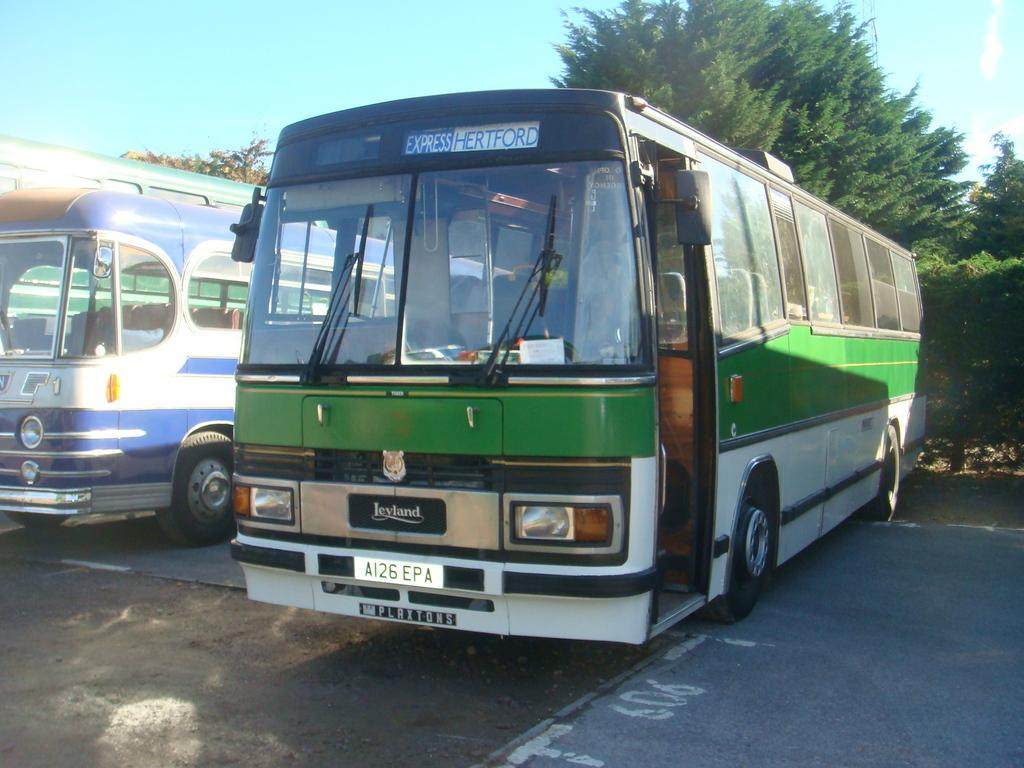<image>
Create a compact narrative representing the image presented. The old green and white bus is listed as following the express Hertford route. 